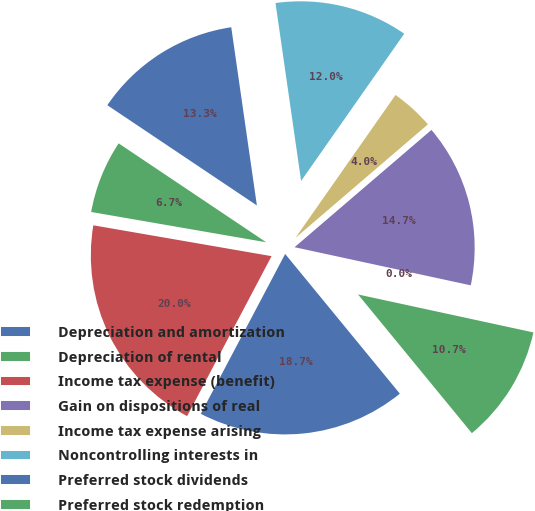Convert chart to OTSL. <chart><loc_0><loc_0><loc_500><loc_500><pie_chart><fcel>Depreciation and amortization<fcel>Depreciation of rental<fcel>Income tax expense (benefit)<fcel>Gain on dispositions of real<fcel>Income tax expense arising<fcel>Noncontrolling interests in<fcel>Preferred stock dividends<fcel>Preferred stock redemption<fcel>FFO<nl><fcel>18.67%<fcel>10.67%<fcel>0.0%<fcel>14.67%<fcel>4.0%<fcel>12.0%<fcel>13.33%<fcel>6.67%<fcel>20.0%<nl></chart> 